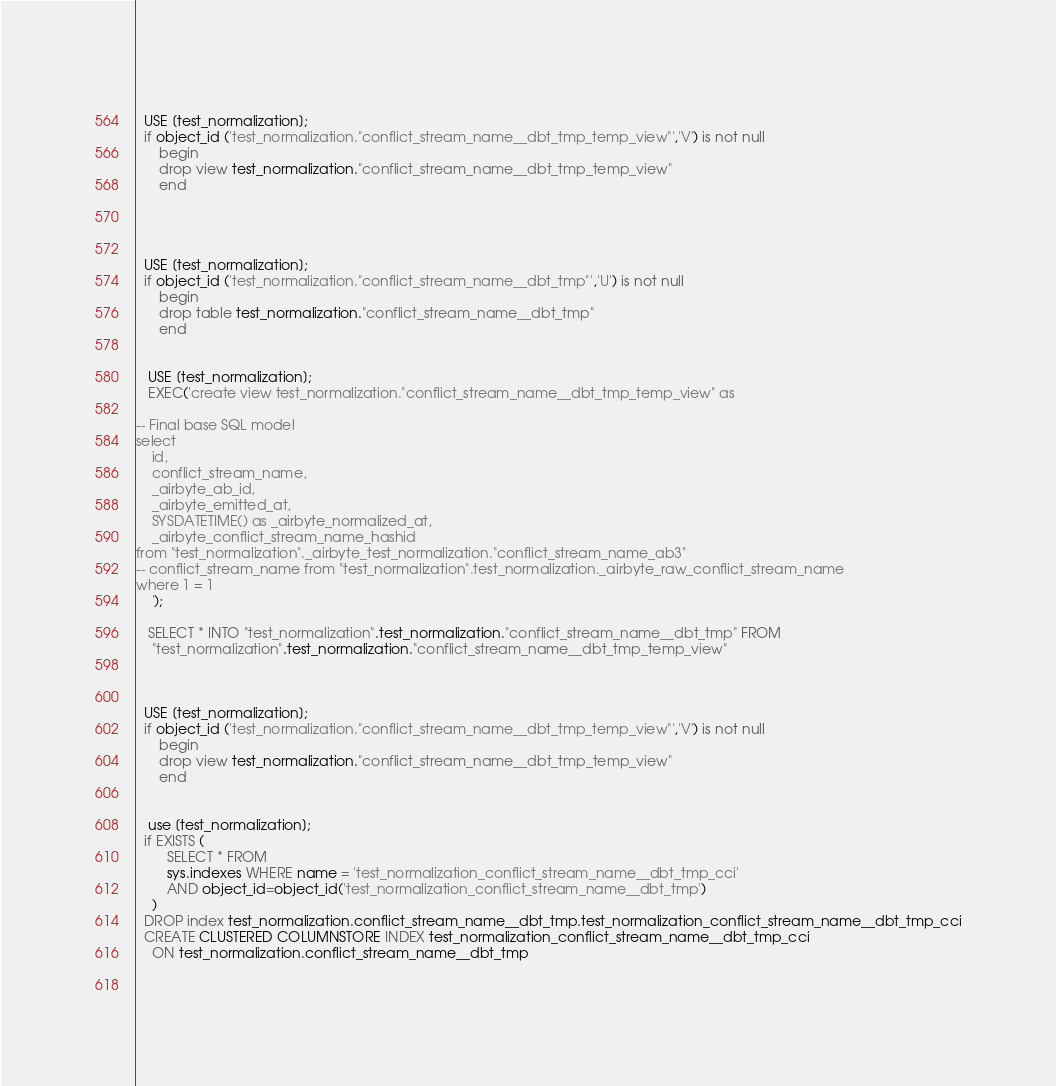Convert code to text. <code><loc_0><loc_0><loc_500><loc_500><_SQL_>
   
  USE [test_normalization];
  if object_id ('test_normalization."conflict_stream_name__dbt_tmp_temp_view"','V') is not null
      begin
      drop view test_normalization."conflict_stream_name__dbt_tmp_temp_view"
      end


   
   
  USE [test_normalization];
  if object_id ('test_normalization."conflict_stream_name__dbt_tmp"','U') is not null
      begin
      drop table test_normalization."conflict_stream_name__dbt_tmp"
      end


   USE [test_normalization];
   EXEC('create view test_normalization."conflict_stream_name__dbt_tmp_temp_view" as
    
-- Final base SQL model
select
    id,
    conflict_stream_name,
    _airbyte_ab_id,
    _airbyte_emitted_at,
    SYSDATETIME() as _airbyte_normalized_at,
    _airbyte_conflict_stream_name_hashid
from "test_normalization"._airbyte_test_normalization."conflict_stream_name_ab3"
-- conflict_stream_name from "test_normalization".test_normalization._airbyte_raw_conflict_stream_name
where 1 = 1
    ');

   SELECT * INTO "test_normalization".test_normalization."conflict_stream_name__dbt_tmp" FROM
    "test_normalization".test_normalization."conflict_stream_name__dbt_tmp_temp_view"

   
   
  USE [test_normalization];
  if object_id ('test_normalization."conflict_stream_name__dbt_tmp_temp_view"','V') is not null
      begin
      drop view test_normalization."conflict_stream_name__dbt_tmp_temp_view"
      end

    
   use [test_normalization];
  if EXISTS (
        SELECT * FROM
        sys.indexes WHERE name = 'test_normalization_conflict_stream_name__dbt_tmp_cci'
        AND object_id=object_id('test_normalization_conflict_stream_name__dbt_tmp')
    )
  DROP index test_normalization.conflict_stream_name__dbt_tmp.test_normalization_conflict_stream_name__dbt_tmp_cci
  CREATE CLUSTERED COLUMNSTORE INDEX test_normalization_conflict_stream_name__dbt_tmp_cci
    ON test_normalization.conflict_stream_name__dbt_tmp

   

</code> 